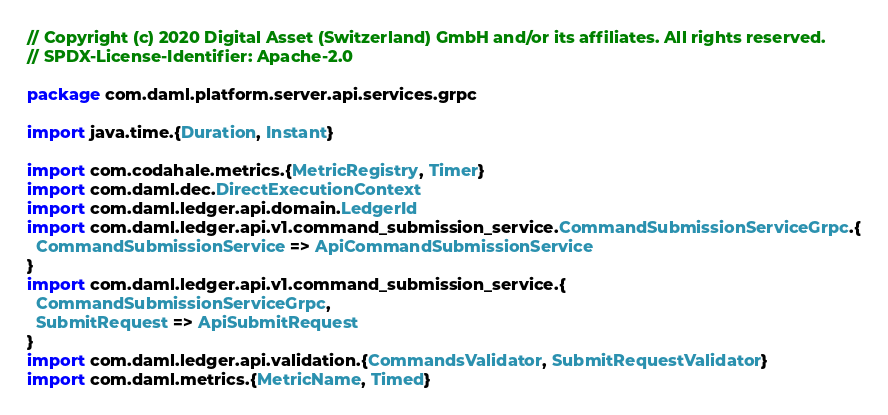Convert code to text. <code><loc_0><loc_0><loc_500><loc_500><_Scala_>// Copyright (c) 2020 Digital Asset (Switzerland) GmbH and/or its affiliates. All rights reserved.
// SPDX-License-Identifier: Apache-2.0

package com.daml.platform.server.api.services.grpc

import java.time.{Duration, Instant}

import com.codahale.metrics.{MetricRegistry, Timer}
import com.daml.dec.DirectExecutionContext
import com.daml.ledger.api.domain.LedgerId
import com.daml.ledger.api.v1.command_submission_service.CommandSubmissionServiceGrpc.{
  CommandSubmissionService => ApiCommandSubmissionService
}
import com.daml.ledger.api.v1.command_submission_service.{
  CommandSubmissionServiceGrpc,
  SubmitRequest => ApiSubmitRequest
}
import com.daml.ledger.api.validation.{CommandsValidator, SubmitRequestValidator}
import com.daml.metrics.{MetricName, Timed}</code> 